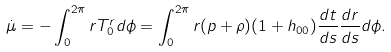<formula> <loc_0><loc_0><loc_500><loc_500>\dot { \mu } = - \int _ { 0 } ^ { 2 \pi } r T ^ { r } _ { 0 } d \phi = \int _ { 0 } ^ { 2 \pi } r ( p + \rho ) ( 1 + h _ { 0 0 } ) \frac { d t } { d s } \frac { d r } { d s } d \phi .</formula> 